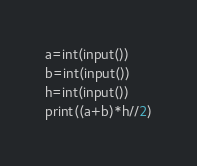Convert code to text. <code><loc_0><loc_0><loc_500><loc_500><_Python_>a=int(input())
b=int(input())
h=int(input())
print((a+b)*h//2)</code> 